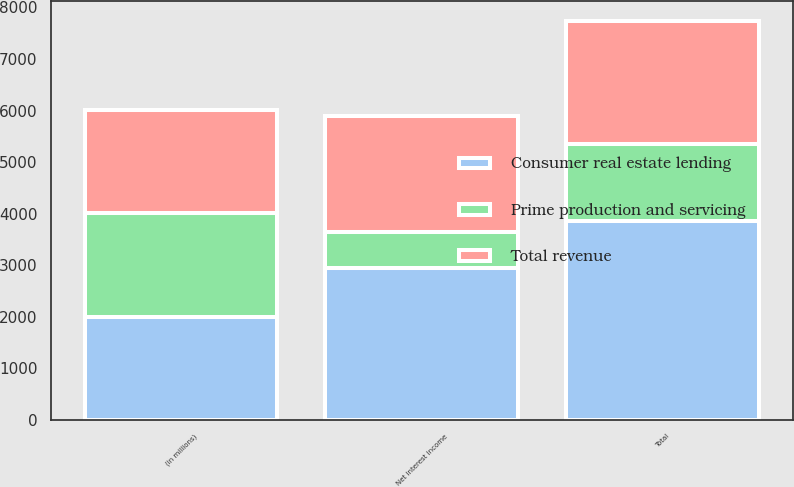Convert chart to OTSL. <chart><loc_0><loc_0><loc_500><loc_500><stacked_bar_chart><ecel><fcel>(in millions)<fcel>Net interest income<fcel>Total<nl><fcel>Prime production and servicing<fcel>2004<fcel>700<fcel>1492<nl><fcel>Total revenue<fcel>2004<fcel>2245<fcel>2376<nl><fcel>Consumer real estate lending<fcel>2004<fcel>2945<fcel>3868<nl></chart> 